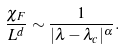Convert formula to latex. <formula><loc_0><loc_0><loc_500><loc_500>\frac { \chi _ { F } } { L ^ { d } } \sim \frac { 1 } { | \lambda - \lambda _ { c } | ^ { \alpha } } .</formula> 